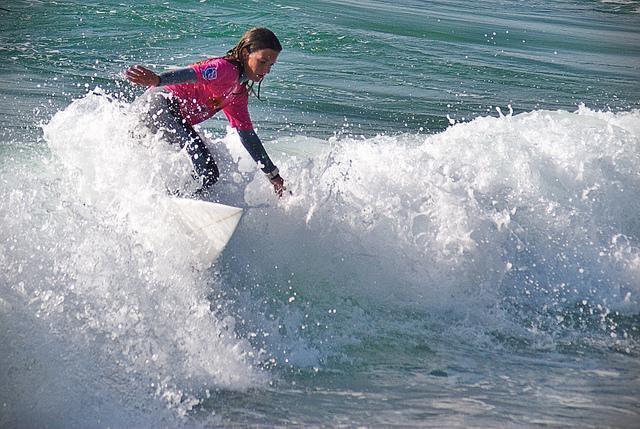How many boats are moving in the photo?
Give a very brief answer. 0. 